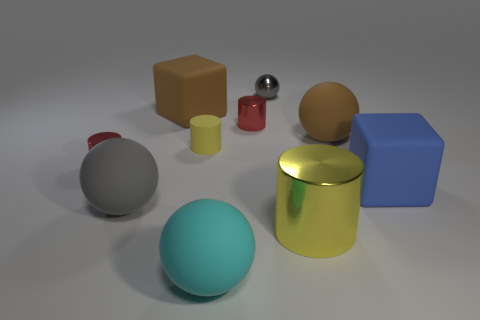Which object stands out the most to you, and why? The teal sphere captures attention due to its vibrant color and the contrasting size compared to the other objects. Its position near the center of the composition also draws the eye and emphasizes its striking hue against the more subdued colors in the background. 